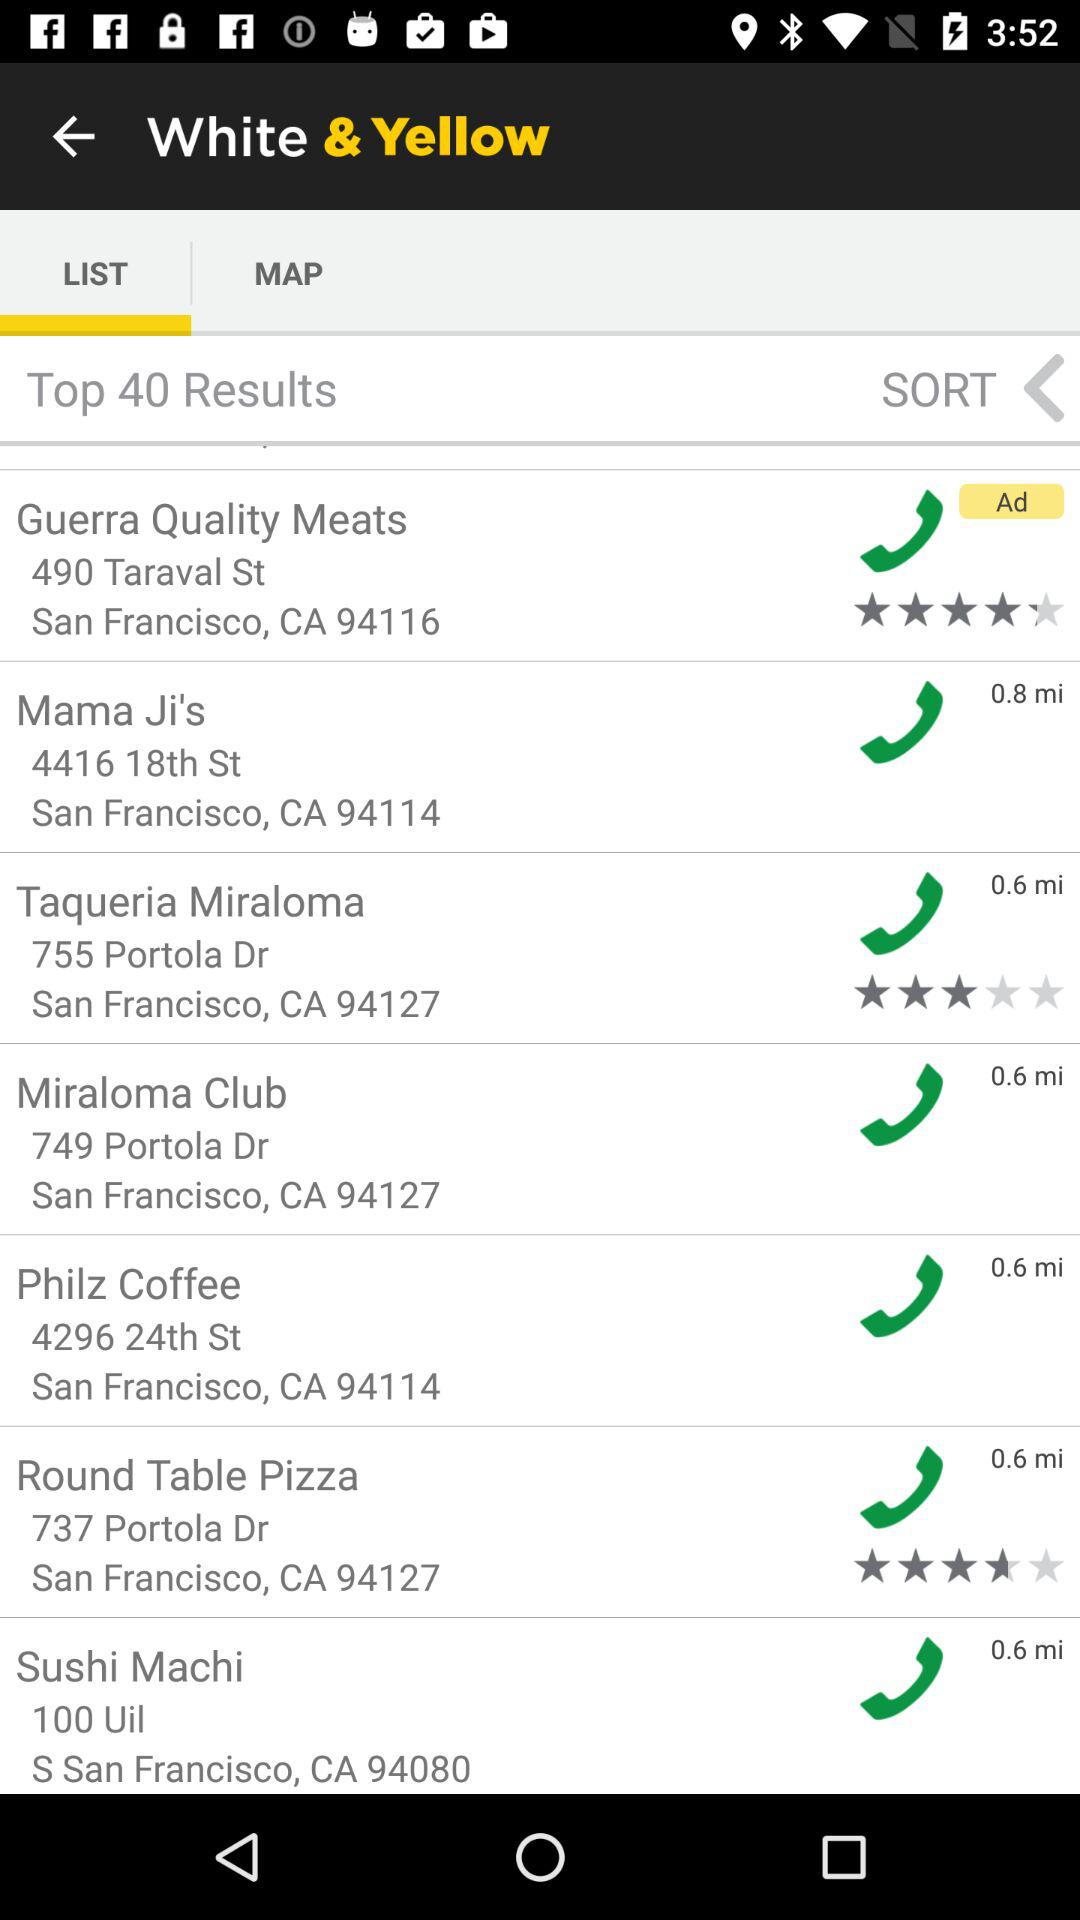How far away is "Sushi Machi"? "Sushi Machi" is 0.6 miles away. 